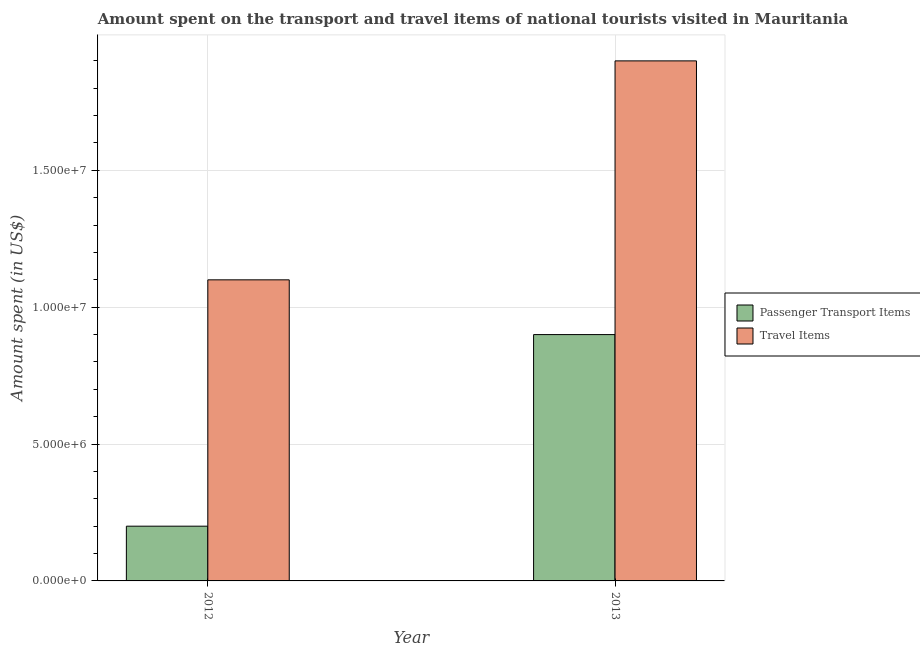How many groups of bars are there?
Ensure brevity in your answer.  2. Are the number of bars per tick equal to the number of legend labels?
Your response must be concise. Yes. Are the number of bars on each tick of the X-axis equal?
Your answer should be very brief. Yes. How many bars are there on the 1st tick from the left?
Your answer should be very brief. 2. How many bars are there on the 1st tick from the right?
Give a very brief answer. 2. In how many cases, is the number of bars for a given year not equal to the number of legend labels?
Give a very brief answer. 0. What is the amount spent on passenger transport items in 2013?
Your answer should be very brief. 9.00e+06. Across all years, what is the maximum amount spent in travel items?
Make the answer very short. 1.90e+07. Across all years, what is the minimum amount spent on passenger transport items?
Ensure brevity in your answer.  2.00e+06. In which year was the amount spent in travel items maximum?
Your response must be concise. 2013. In which year was the amount spent in travel items minimum?
Offer a terse response. 2012. What is the total amount spent in travel items in the graph?
Provide a short and direct response. 3.00e+07. What is the difference between the amount spent in travel items in 2012 and that in 2013?
Your answer should be very brief. -8.00e+06. What is the difference between the amount spent on passenger transport items in 2013 and the amount spent in travel items in 2012?
Your response must be concise. 7.00e+06. What is the average amount spent in travel items per year?
Your response must be concise. 1.50e+07. In the year 2013, what is the difference between the amount spent on passenger transport items and amount spent in travel items?
Provide a succinct answer. 0. What is the ratio of the amount spent in travel items in 2012 to that in 2013?
Give a very brief answer. 0.58. Is the amount spent on passenger transport items in 2012 less than that in 2013?
Give a very brief answer. Yes. In how many years, is the amount spent on passenger transport items greater than the average amount spent on passenger transport items taken over all years?
Give a very brief answer. 1. What does the 1st bar from the left in 2012 represents?
Give a very brief answer. Passenger Transport Items. What does the 2nd bar from the right in 2013 represents?
Provide a succinct answer. Passenger Transport Items. How many bars are there?
Provide a short and direct response. 4. How many years are there in the graph?
Make the answer very short. 2. What is the difference between two consecutive major ticks on the Y-axis?
Provide a short and direct response. 5.00e+06. How many legend labels are there?
Keep it short and to the point. 2. What is the title of the graph?
Offer a terse response. Amount spent on the transport and travel items of national tourists visited in Mauritania. Does "Fertility rate" appear as one of the legend labels in the graph?
Your response must be concise. No. What is the label or title of the Y-axis?
Provide a short and direct response. Amount spent (in US$). What is the Amount spent (in US$) in Travel Items in 2012?
Your answer should be very brief. 1.10e+07. What is the Amount spent (in US$) of Passenger Transport Items in 2013?
Offer a terse response. 9.00e+06. What is the Amount spent (in US$) of Travel Items in 2013?
Your answer should be very brief. 1.90e+07. Across all years, what is the maximum Amount spent (in US$) in Passenger Transport Items?
Your answer should be compact. 9.00e+06. Across all years, what is the maximum Amount spent (in US$) in Travel Items?
Ensure brevity in your answer.  1.90e+07. Across all years, what is the minimum Amount spent (in US$) of Passenger Transport Items?
Ensure brevity in your answer.  2.00e+06. Across all years, what is the minimum Amount spent (in US$) of Travel Items?
Your answer should be very brief. 1.10e+07. What is the total Amount spent (in US$) in Passenger Transport Items in the graph?
Offer a very short reply. 1.10e+07. What is the total Amount spent (in US$) in Travel Items in the graph?
Provide a short and direct response. 3.00e+07. What is the difference between the Amount spent (in US$) in Passenger Transport Items in 2012 and that in 2013?
Provide a succinct answer. -7.00e+06. What is the difference between the Amount spent (in US$) of Travel Items in 2012 and that in 2013?
Make the answer very short. -8.00e+06. What is the difference between the Amount spent (in US$) in Passenger Transport Items in 2012 and the Amount spent (in US$) in Travel Items in 2013?
Provide a short and direct response. -1.70e+07. What is the average Amount spent (in US$) of Passenger Transport Items per year?
Offer a terse response. 5.50e+06. What is the average Amount spent (in US$) in Travel Items per year?
Make the answer very short. 1.50e+07. In the year 2012, what is the difference between the Amount spent (in US$) of Passenger Transport Items and Amount spent (in US$) of Travel Items?
Make the answer very short. -9.00e+06. In the year 2013, what is the difference between the Amount spent (in US$) in Passenger Transport Items and Amount spent (in US$) in Travel Items?
Keep it short and to the point. -1.00e+07. What is the ratio of the Amount spent (in US$) in Passenger Transport Items in 2012 to that in 2013?
Your answer should be very brief. 0.22. What is the ratio of the Amount spent (in US$) in Travel Items in 2012 to that in 2013?
Keep it short and to the point. 0.58. What is the difference between the highest and the second highest Amount spent (in US$) in Passenger Transport Items?
Offer a terse response. 7.00e+06. What is the difference between the highest and the second highest Amount spent (in US$) in Travel Items?
Keep it short and to the point. 8.00e+06. What is the difference between the highest and the lowest Amount spent (in US$) in Travel Items?
Your answer should be compact. 8.00e+06. 